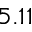Convert formula to latex. <formula><loc_0><loc_0><loc_500><loc_500>5 . 1 1</formula> 